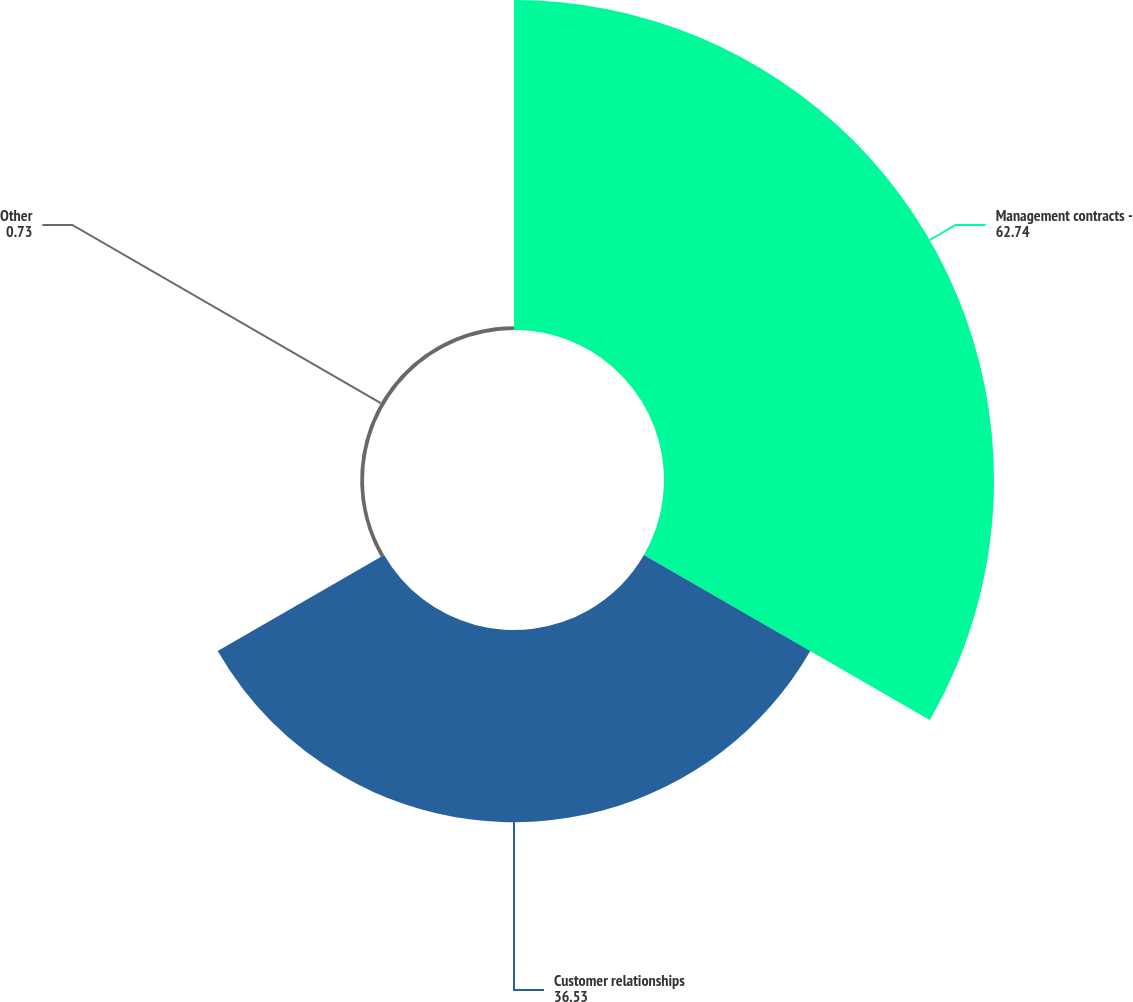Convert chart to OTSL. <chart><loc_0><loc_0><loc_500><loc_500><pie_chart><fcel>Management contracts -<fcel>Customer relationships<fcel>Other<nl><fcel>62.74%<fcel>36.53%<fcel>0.73%<nl></chart> 